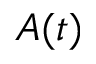<formula> <loc_0><loc_0><loc_500><loc_500>A ( t )</formula> 